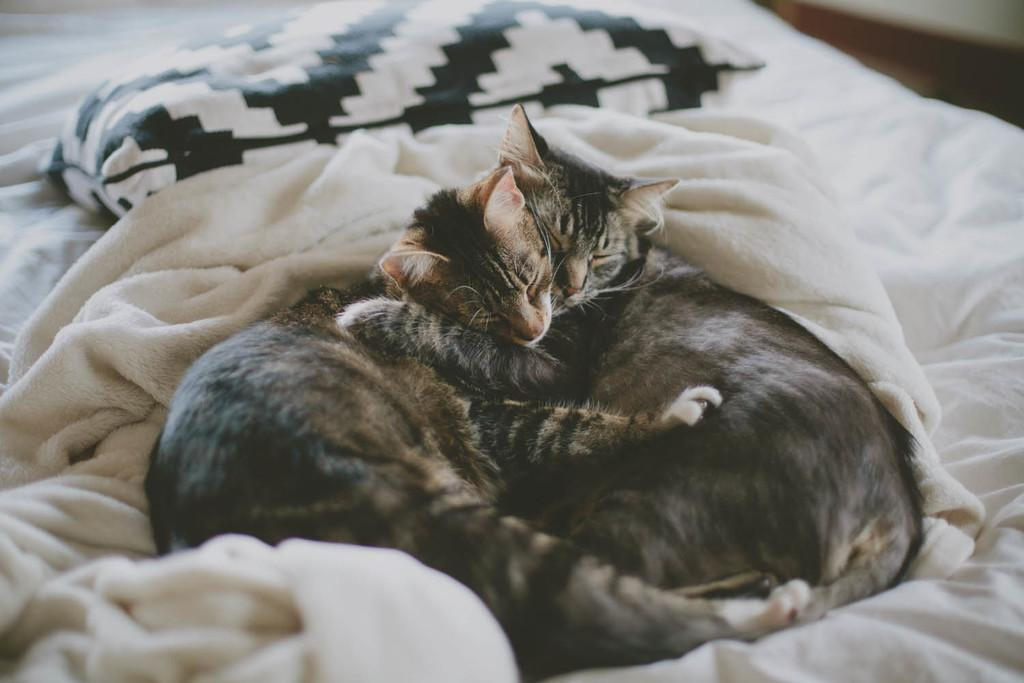What type of animals can be seen in the image? There are cats in the image. What are the cats doing in the image? The cats are sleeping on the bed. What is located at the top of the bed? There is a cushion at the top of the bed. What type of bedding is visible in the image? There is a blanket visible in the image. What type of jam is being spread on the pear in the image? There is no jam or pear present in the image; it features cats sleeping on a bed. 